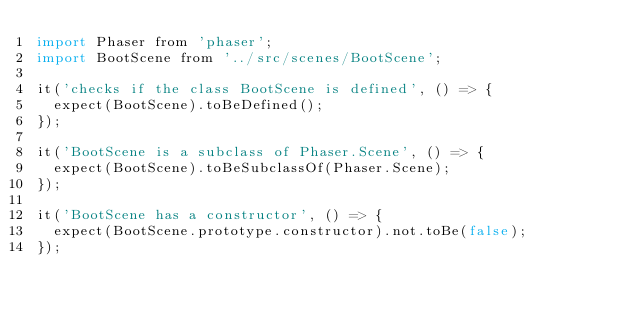<code> <loc_0><loc_0><loc_500><loc_500><_JavaScript_>import Phaser from 'phaser';
import BootScene from '../src/scenes/BootScene';

it('checks if the class BootScene is defined', () => {
  expect(BootScene).toBeDefined();
});

it('BootScene is a subclass of Phaser.Scene', () => {
  expect(BootScene).toBeSubclassOf(Phaser.Scene);
});

it('BootScene has a constructor', () => {
  expect(BootScene.prototype.constructor).not.toBe(false);
});
</code> 